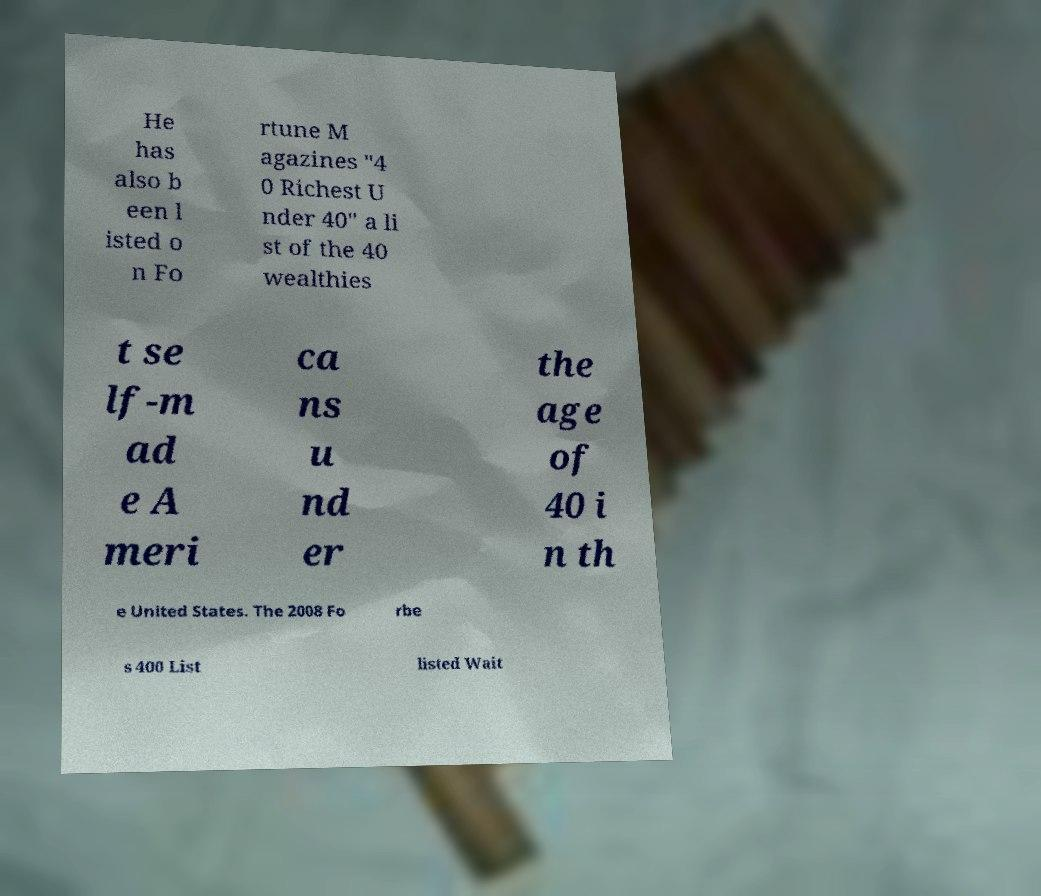Can you accurately transcribe the text from the provided image for me? He has also b een l isted o n Fo rtune M agazines "4 0 Richest U nder 40" a li st of the 40 wealthies t se lf-m ad e A meri ca ns u nd er the age of 40 i n th e United States. The 2008 Fo rbe s 400 List listed Wait 